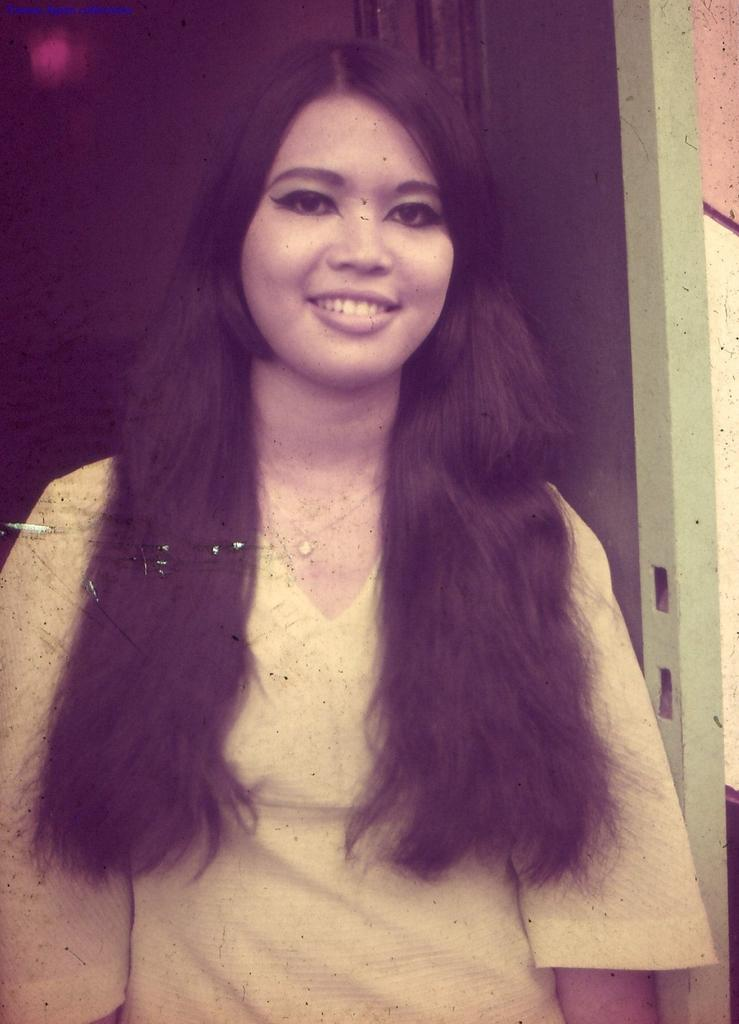Who is present in the image? There is a woman in the image. What is the woman doing in the image? The woman is smiling. What type of branch is the woman holding in the image? There is no branch present in the image; it only features a woman who is smiling. 